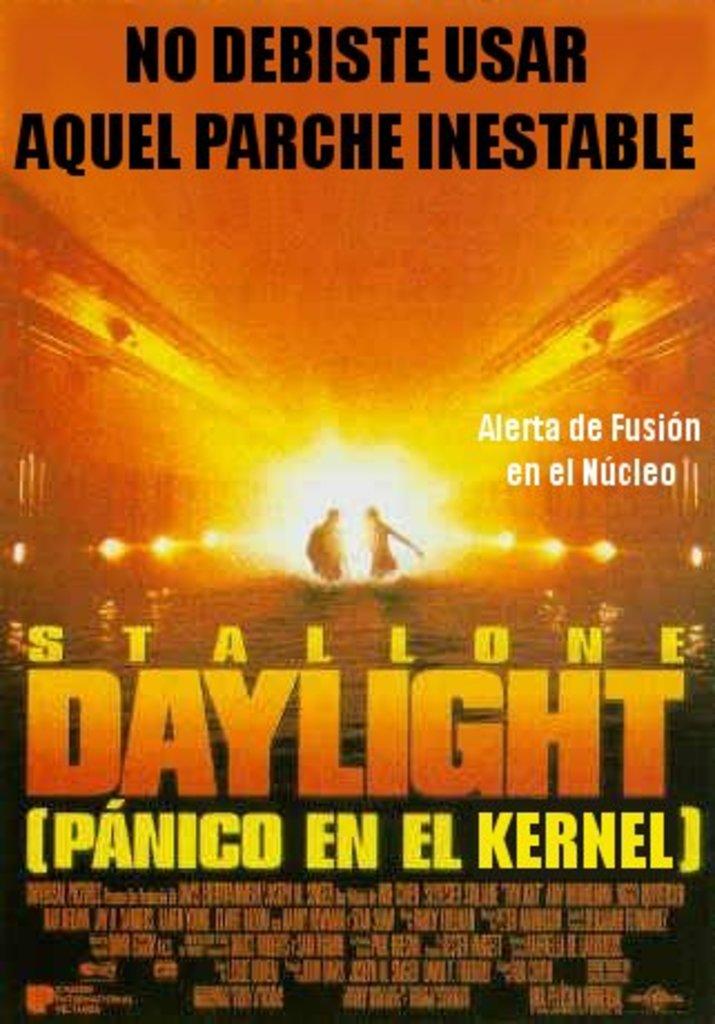What's the english name of the stallone film?
Offer a terse response. Daylight. What famous actor stars in this film?
Provide a succinct answer. Unanswerable. 